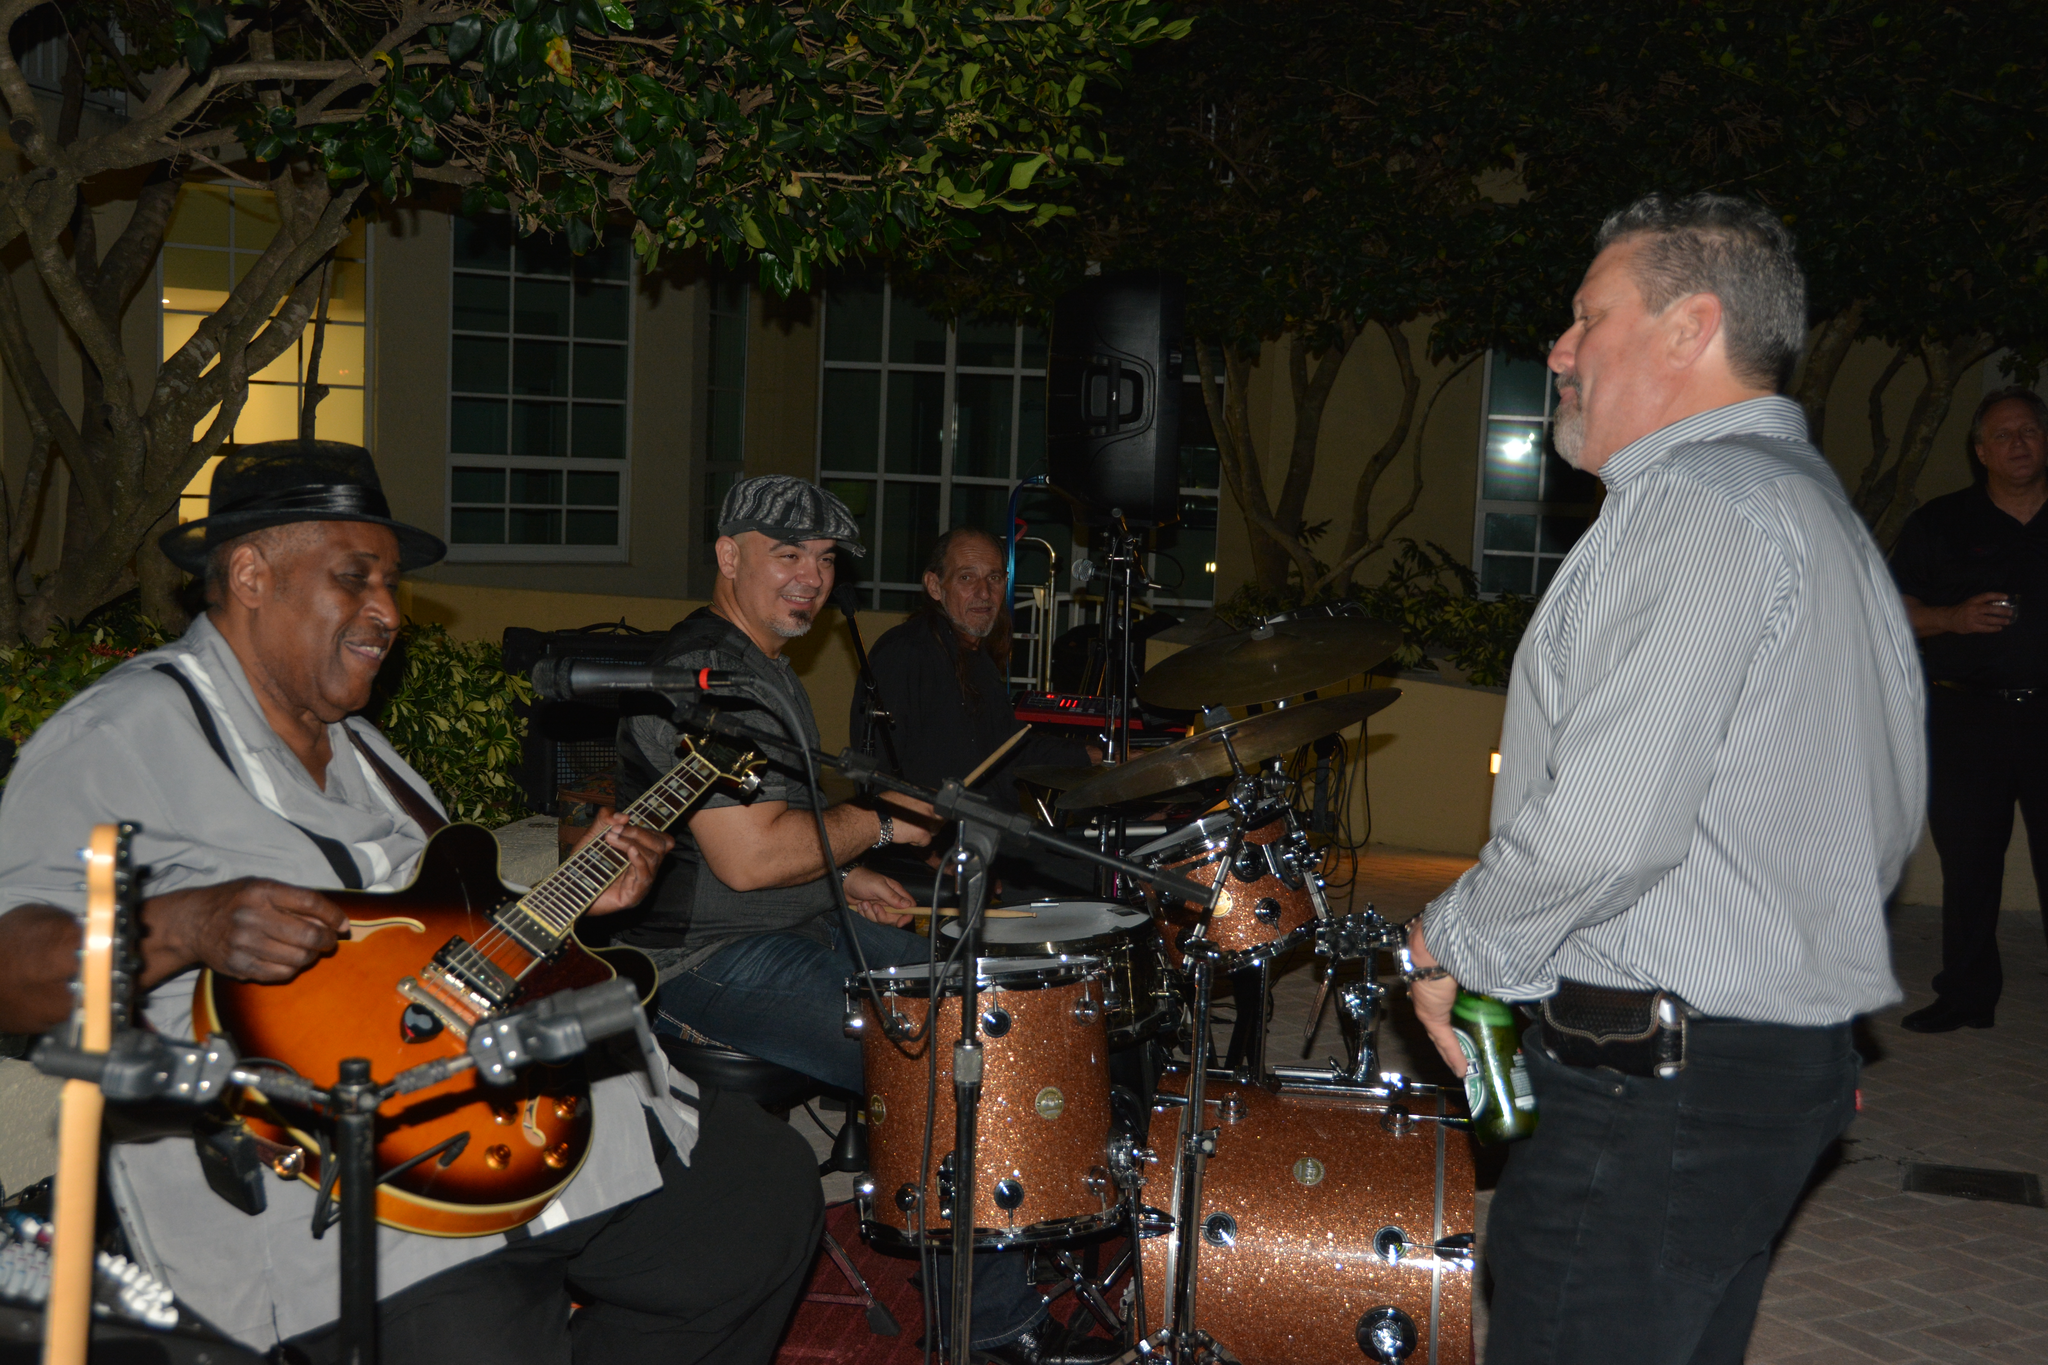Could you give a brief overview of what you see in this image? In this image I see 4 men, in which 3 of them are near the musical instruments and this man is holding the bottle. In the background I see building, a person over here and the trees. 